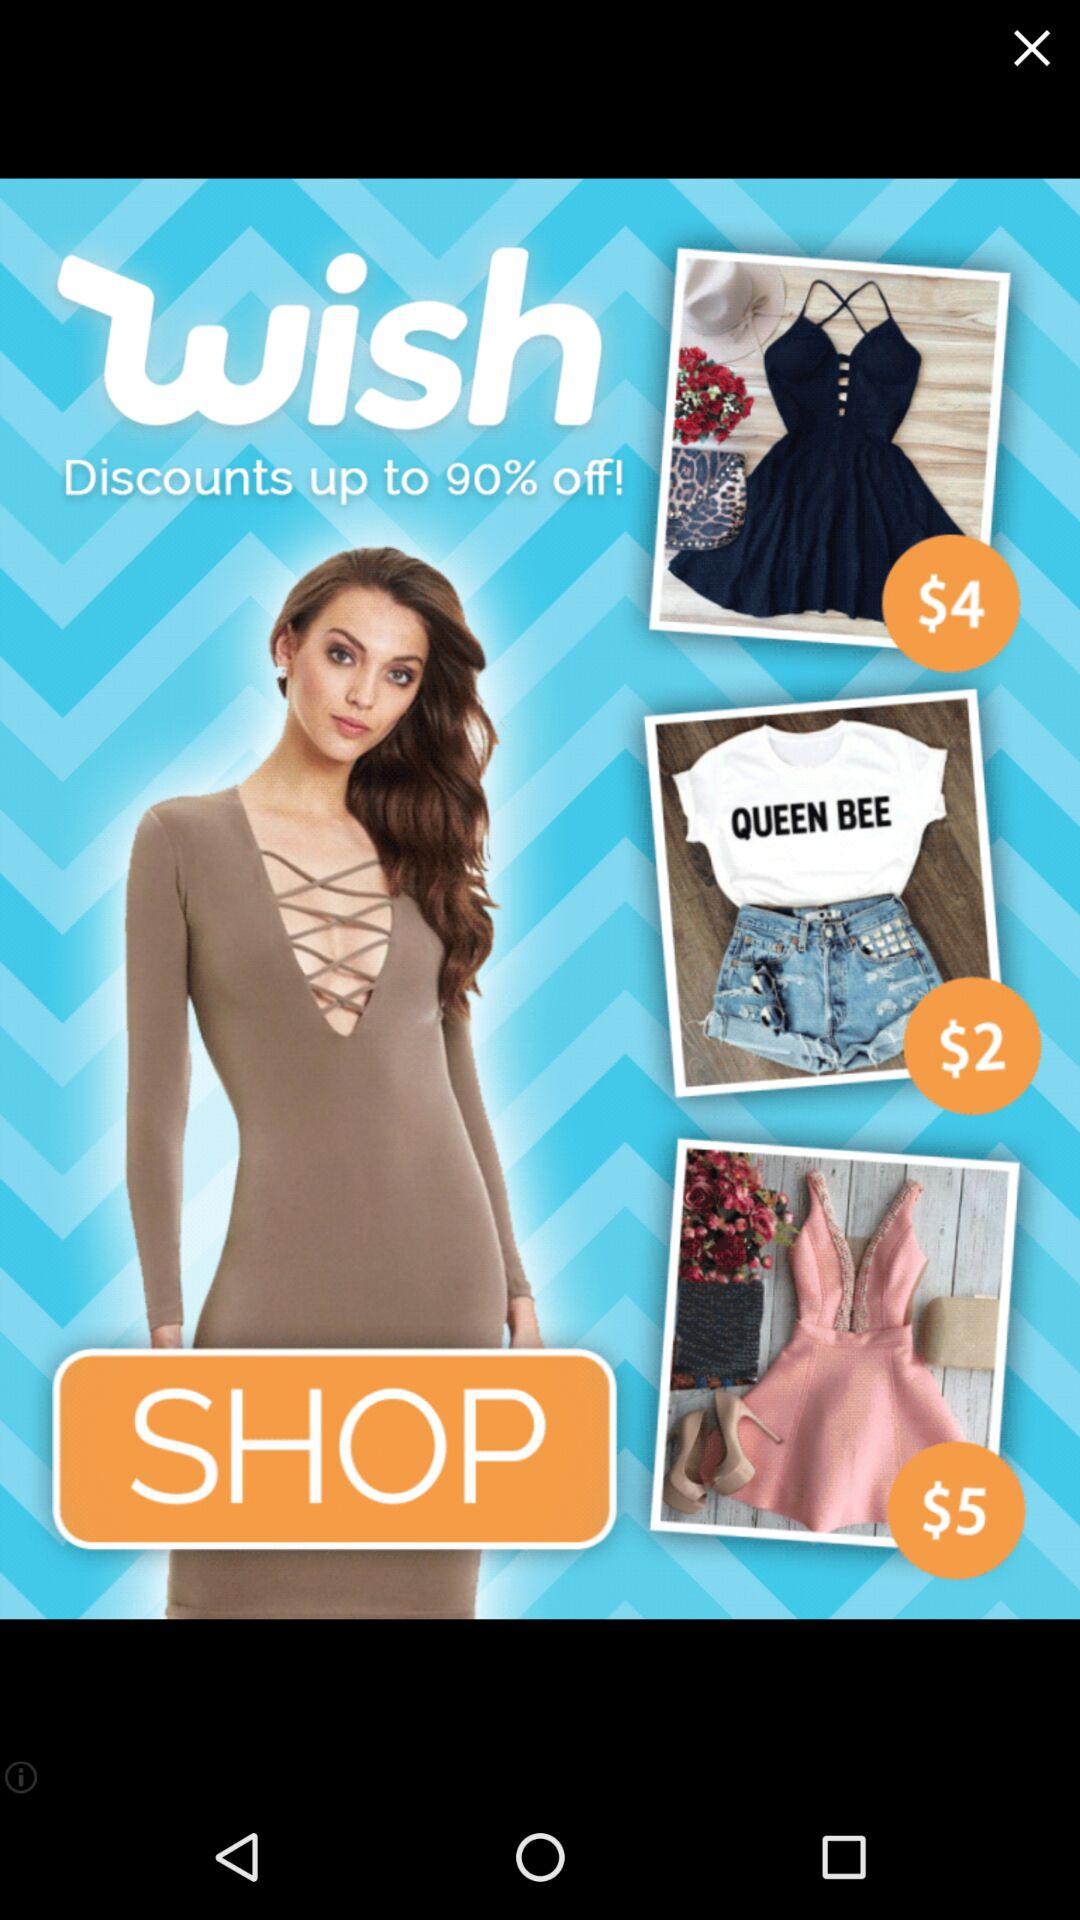How many dresses have a price less than $5?
Answer the question using a single word or phrase. 2 